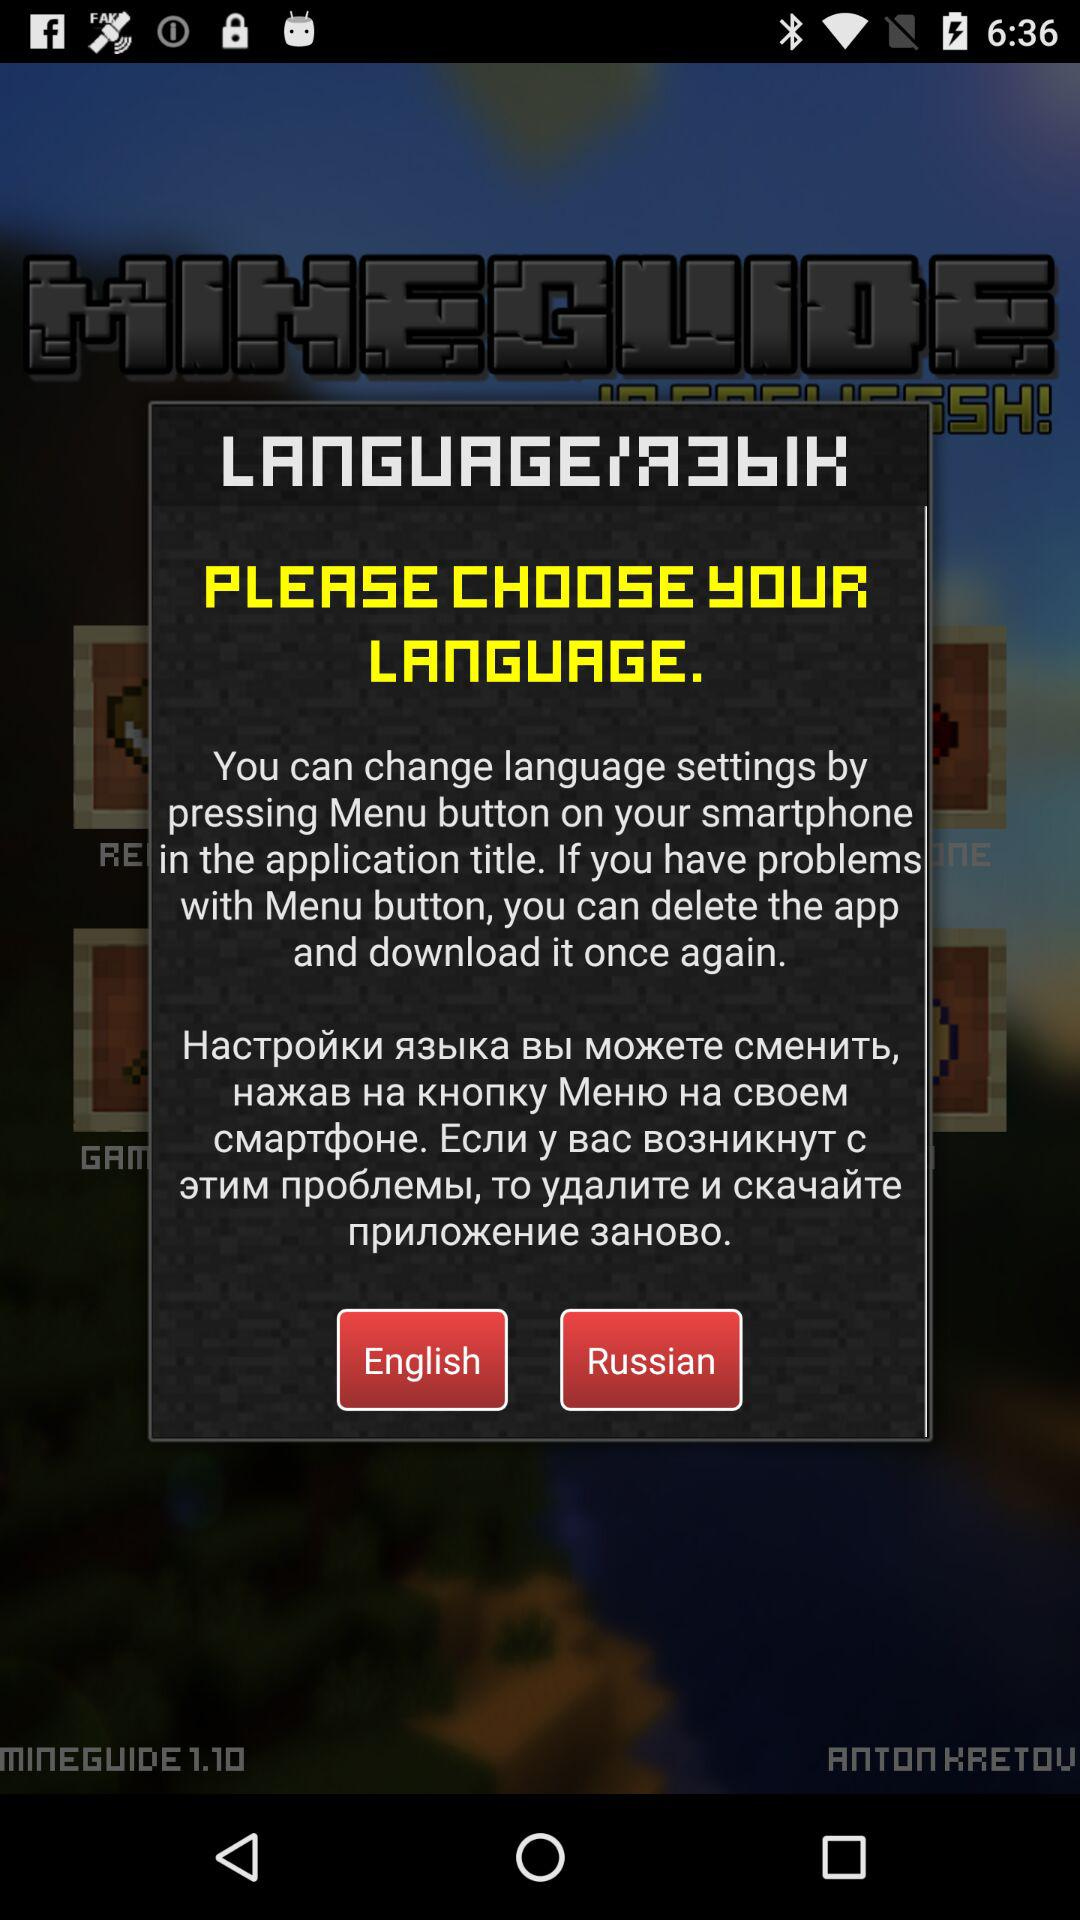How many languages are available to choose from?
Answer the question using a single word or phrase. 2 